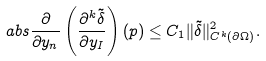Convert formula to latex. <formula><loc_0><loc_0><loc_500><loc_500>\ a b s { \frac { \partial } { \partial y _ { n } } \left ( \frac { \partial ^ { k } \tilde { \delta } } { \partial y _ { I } } \right ) ( p ) } \leq C _ { 1 } \| \tilde { \delta } \| _ { C ^ { k } ( \partial \Omega ) } ^ { 2 } .</formula> 